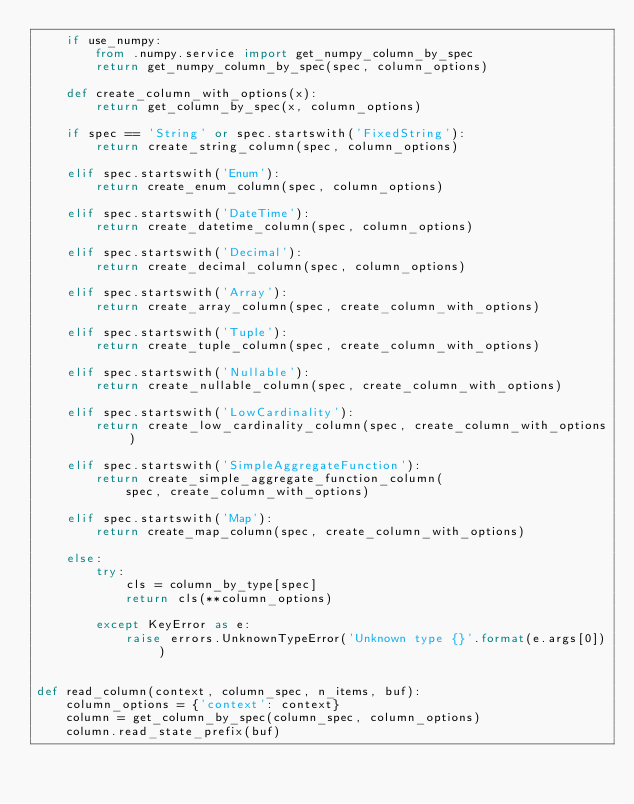<code> <loc_0><loc_0><loc_500><loc_500><_Python_>    if use_numpy:
        from .numpy.service import get_numpy_column_by_spec
        return get_numpy_column_by_spec(spec, column_options)

    def create_column_with_options(x):
        return get_column_by_spec(x, column_options)

    if spec == 'String' or spec.startswith('FixedString'):
        return create_string_column(spec, column_options)

    elif spec.startswith('Enum'):
        return create_enum_column(spec, column_options)

    elif spec.startswith('DateTime'):
        return create_datetime_column(spec, column_options)

    elif spec.startswith('Decimal'):
        return create_decimal_column(spec, column_options)

    elif spec.startswith('Array'):
        return create_array_column(spec, create_column_with_options)

    elif spec.startswith('Tuple'):
        return create_tuple_column(spec, create_column_with_options)

    elif spec.startswith('Nullable'):
        return create_nullable_column(spec, create_column_with_options)

    elif spec.startswith('LowCardinality'):
        return create_low_cardinality_column(spec, create_column_with_options)

    elif spec.startswith('SimpleAggregateFunction'):
        return create_simple_aggregate_function_column(
            spec, create_column_with_options)

    elif spec.startswith('Map'):
        return create_map_column(spec, create_column_with_options)

    else:
        try:
            cls = column_by_type[spec]
            return cls(**column_options)

        except KeyError as e:
            raise errors.UnknownTypeError('Unknown type {}'.format(e.args[0]))


def read_column(context, column_spec, n_items, buf):
    column_options = {'context': context}
    column = get_column_by_spec(column_spec, column_options)
    column.read_state_prefix(buf)</code> 